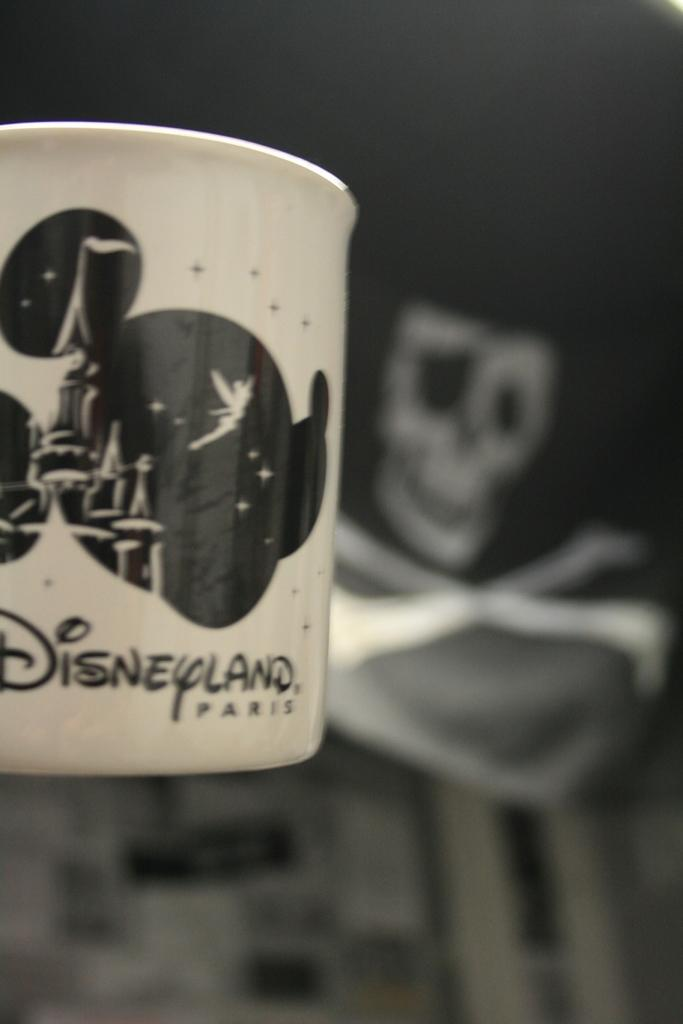<image>
Summarize the visual content of the image. A white and black Disneyland cup is shown 